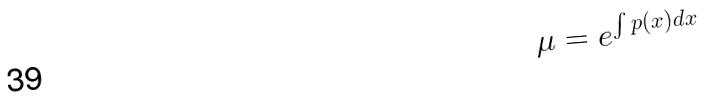<formula> <loc_0><loc_0><loc_500><loc_500>\mu = e ^ { \int p ( x ) d x }</formula> 